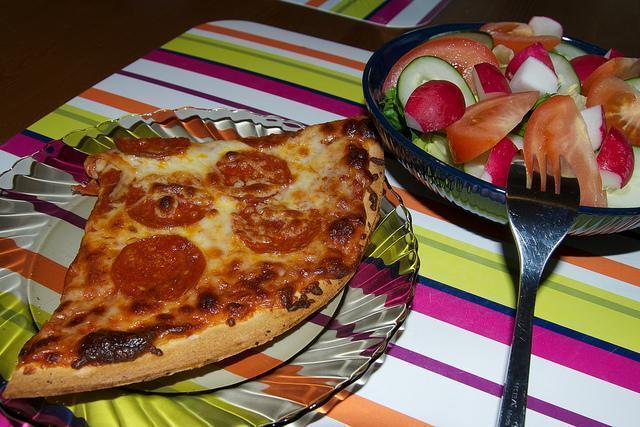What kind of side meal is there a serving of near the pizza?
Pick the correct solution from the four options below to address the question.
Options: Parsley, potato chips, salad, french fries. Salad. 